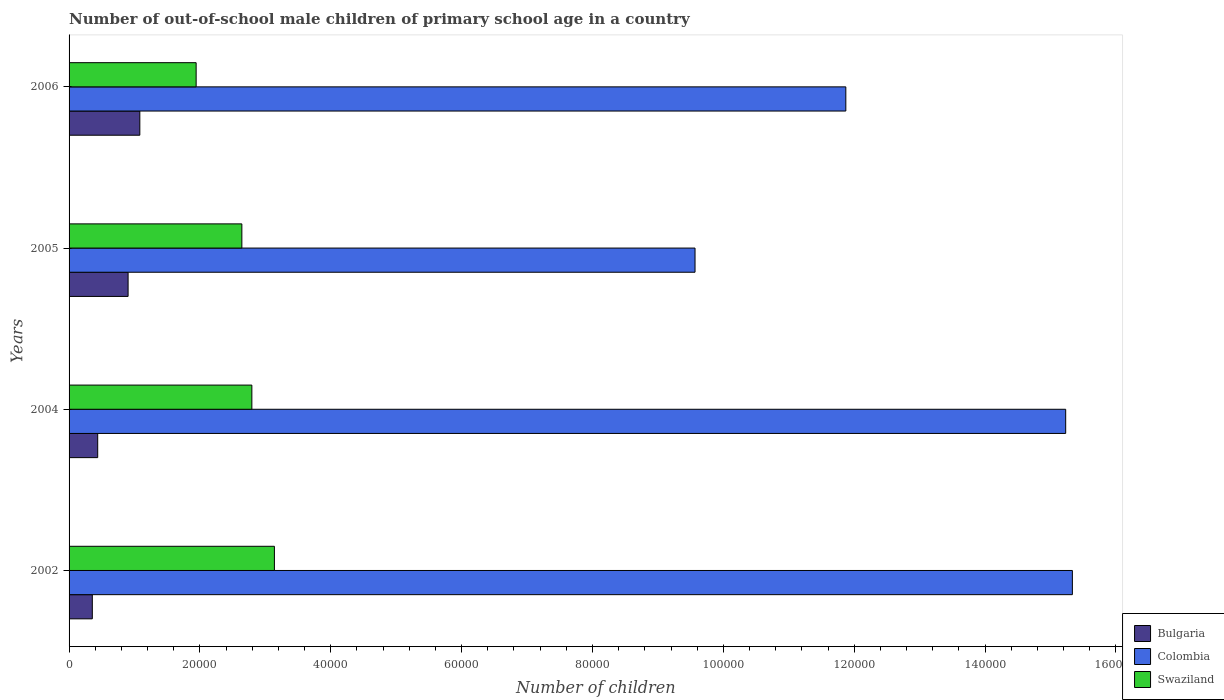Are the number of bars per tick equal to the number of legend labels?
Offer a very short reply. Yes. Are the number of bars on each tick of the Y-axis equal?
Make the answer very short. Yes. How many bars are there on the 4th tick from the bottom?
Provide a short and direct response. 3. What is the label of the 3rd group of bars from the top?
Your answer should be compact. 2004. In how many cases, is the number of bars for a given year not equal to the number of legend labels?
Provide a short and direct response. 0. What is the number of out-of-school male children in Colombia in 2005?
Provide a succinct answer. 9.57e+04. Across all years, what is the maximum number of out-of-school male children in Colombia?
Make the answer very short. 1.53e+05. Across all years, what is the minimum number of out-of-school male children in Swaziland?
Offer a very short reply. 1.94e+04. In which year was the number of out-of-school male children in Colombia maximum?
Provide a short and direct response. 2002. In which year was the number of out-of-school male children in Colombia minimum?
Provide a succinct answer. 2005. What is the total number of out-of-school male children in Colombia in the graph?
Your answer should be very brief. 5.20e+05. What is the difference between the number of out-of-school male children in Bulgaria in 2005 and that in 2006?
Make the answer very short. -1793. What is the difference between the number of out-of-school male children in Colombia in 2004 and the number of out-of-school male children in Swaziland in 2006?
Ensure brevity in your answer.  1.33e+05. What is the average number of out-of-school male children in Bulgaria per year?
Ensure brevity in your answer.  6941.25. In the year 2005, what is the difference between the number of out-of-school male children in Bulgaria and number of out-of-school male children in Colombia?
Offer a very short reply. -8.66e+04. What is the ratio of the number of out-of-school male children in Swaziland in 2002 to that in 2006?
Offer a very short reply. 1.62. Is the difference between the number of out-of-school male children in Bulgaria in 2005 and 2006 greater than the difference between the number of out-of-school male children in Colombia in 2005 and 2006?
Provide a short and direct response. Yes. What is the difference between the highest and the second highest number of out-of-school male children in Colombia?
Your answer should be compact. 1021. What is the difference between the highest and the lowest number of out-of-school male children in Bulgaria?
Keep it short and to the point. 7262. In how many years, is the number of out-of-school male children in Swaziland greater than the average number of out-of-school male children in Swaziland taken over all years?
Make the answer very short. 3. Is the sum of the number of out-of-school male children in Swaziland in 2005 and 2006 greater than the maximum number of out-of-school male children in Bulgaria across all years?
Offer a very short reply. Yes. What does the 1st bar from the bottom in 2004 represents?
Your answer should be compact. Bulgaria. Are all the bars in the graph horizontal?
Your answer should be very brief. Yes. What is the difference between two consecutive major ticks on the X-axis?
Ensure brevity in your answer.  2.00e+04. Does the graph contain any zero values?
Offer a very short reply. No. Where does the legend appear in the graph?
Offer a terse response. Bottom right. How many legend labels are there?
Give a very brief answer. 3. How are the legend labels stacked?
Provide a succinct answer. Vertical. What is the title of the graph?
Ensure brevity in your answer.  Number of out-of-school male children of primary school age in a country. What is the label or title of the X-axis?
Make the answer very short. Number of children. What is the label or title of the Y-axis?
Your response must be concise. Years. What is the Number of children in Bulgaria in 2002?
Give a very brief answer. 3553. What is the Number of children of Colombia in 2002?
Keep it short and to the point. 1.53e+05. What is the Number of children of Swaziland in 2002?
Make the answer very short. 3.14e+04. What is the Number of children of Bulgaria in 2004?
Ensure brevity in your answer.  4375. What is the Number of children in Colombia in 2004?
Offer a terse response. 1.52e+05. What is the Number of children in Swaziland in 2004?
Provide a short and direct response. 2.79e+04. What is the Number of children in Bulgaria in 2005?
Your answer should be compact. 9022. What is the Number of children of Colombia in 2005?
Keep it short and to the point. 9.57e+04. What is the Number of children in Swaziland in 2005?
Provide a short and direct response. 2.64e+04. What is the Number of children in Bulgaria in 2006?
Provide a short and direct response. 1.08e+04. What is the Number of children in Colombia in 2006?
Ensure brevity in your answer.  1.19e+05. What is the Number of children in Swaziland in 2006?
Keep it short and to the point. 1.94e+04. Across all years, what is the maximum Number of children in Bulgaria?
Ensure brevity in your answer.  1.08e+04. Across all years, what is the maximum Number of children of Colombia?
Offer a terse response. 1.53e+05. Across all years, what is the maximum Number of children in Swaziland?
Offer a terse response. 3.14e+04. Across all years, what is the minimum Number of children of Bulgaria?
Ensure brevity in your answer.  3553. Across all years, what is the minimum Number of children of Colombia?
Make the answer very short. 9.57e+04. Across all years, what is the minimum Number of children in Swaziland?
Your answer should be compact. 1.94e+04. What is the total Number of children of Bulgaria in the graph?
Your answer should be very brief. 2.78e+04. What is the total Number of children in Colombia in the graph?
Your answer should be very brief. 5.20e+05. What is the total Number of children of Swaziland in the graph?
Offer a very short reply. 1.05e+05. What is the difference between the Number of children in Bulgaria in 2002 and that in 2004?
Your response must be concise. -822. What is the difference between the Number of children of Colombia in 2002 and that in 2004?
Offer a very short reply. 1021. What is the difference between the Number of children in Swaziland in 2002 and that in 2004?
Offer a very short reply. 3445. What is the difference between the Number of children of Bulgaria in 2002 and that in 2005?
Make the answer very short. -5469. What is the difference between the Number of children of Colombia in 2002 and that in 2005?
Provide a short and direct response. 5.77e+04. What is the difference between the Number of children of Swaziland in 2002 and that in 2005?
Provide a succinct answer. 4974. What is the difference between the Number of children in Bulgaria in 2002 and that in 2006?
Your answer should be very brief. -7262. What is the difference between the Number of children of Colombia in 2002 and that in 2006?
Make the answer very short. 3.46e+04. What is the difference between the Number of children of Swaziland in 2002 and that in 2006?
Your response must be concise. 1.20e+04. What is the difference between the Number of children of Bulgaria in 2004 and that in 2005?
Keep it short and to the point. -4647. What is the difference between the Number of children of Colombia in 2004 and that in 2005?
Keep it short and to the point. 5.67e+04. What is the difference between the Number of children in Swaziland in 2004 and that in 2005?
Provide a short and direct response. 1529. What is the difference between the Number of children of Bulgaria in 2004 and that in 2006?
Keep it short and to the point. -6440. What is the difference between the Number of children in Colombia in 2004 and that in 2006?
Your answer should be compact. 3.36e+04. What is the difference between the Number of children in Swaziland in 2004 and that in 2006?
Make the answer very short. 8516. What is the difference between the Number of children of Bulgaria in 2005 and that in 2006?
Make the answer very short. -1793. What is the difference between the Number of children in Colombia in 2005 and that in 2006?
Your response must be concise. -2.30e+04. What is the difference between the Number of children in Swaziland in 2005 and that in 2006?
Your answer should be compact. 6987. What is the difference between the Number of children of Bulgaria in 2002 and the Number of children of Colombia in 2004?
Make the answer very short. -1.49e+05. What is the difference between the Number of children of Bulgaria in 2002 and the Number of children of Swaziland in 2004?
Your answer should be very brief. -2.44e+04. What is the difference between the Number of children of Colombia in 2002 and the Number of children of Swaziland in 2004?
Make the answer very short. 1.25e+05. What is the difference between the Number of children of Bulgaria in 2002 and the Number of children of Colombia in 2005?
Ensure brevity in your answer.  -9.21e+04. What is the difference between the Number of children of Bulgaria in 2002 and the Number of children of Swaziland in 2005?
Offer a very short reply. -2.29e+04. What is the difference between the Number of children of Colombia in 2002 and the Number of children of Swaziland in 2005?
Your response must be concise. 1.27e+05. What is the difference between the Number of children in Bulgaria in 2002 and the Number of children in Colombia in 2006?
Provide a short and direct response. -1.15e+05. What is the difference between the Number of children of Bulgaria in 2002 and the Number of children of Swaziland in 2006?
Ensure brevity in your answer.  -1.59e+04. What is the difference between the Number of children of Colombia in 2002 and the Number of children of Swaziland in 2006?
Ensure brevity in your answer.  1.34e+05. What is the difference between the Number of children in Bulgaria in 2004 and the Number of children in Colombia in 2005?
Your answer should be compact. -9.13e+04. What is the difference between the Number of children of Bulgaria in 2004 and the Number of children of Swaziland in 2005?
Give a very brief answer. -2.20e+04. What is the difference between the Number of children of Colombia in 2004 and the Number of children of Swaziland in 2005?
Offer a terse response. 1.26e+05. What is the difference between the Number of children of Bulgaria in 2004 and the Number of children of Colombia in 2006?
Offer a very short reply. -1.14e+05. What is the difference between the Number of children of Bulgaria in 2004 and the Number of children of Swaziland in 2006?
Your answer should be compact. -1.50e+04. What is the difference between the Number of children in Colombia in 2004 and the Number of children in Swaziland in 2006?
Ensure brevity in your answer.  1.33e+05. What is the difference between the Number of children of Bulgaria in 2005 and the Number of children of Colombia in 2006?
Provide a short and direct response. -1.10e+05. What is the difference between the Number of children in Bulgaria in 2005 and the Number of children in Swaziland in 2006?
Your answer should be very brief. -1.04e+04. What is the difference between the Number of children of Colombia in 2005 and the Number of children of Swaziland in 2006?
Keep it short and to the point. 7.62e+04. What is the average Number of children of Bulgaria per year?
Offer a terse response. 6941.25. What is the average Number of children in Colombia per year?
Provide a succinct answer. 1.30e+05. What is the average Number of children in Swaziland per year?
Offer a very short reply. 2.63e+04. In the year 2002, what is the difference between the Number of children of Bulgaria and Number of children of Colombia?
Offer a very short reply. -1.50e+05. In the year 2002, what is the difference between the Number of children in Bulgaria and Number of children in Swaziland?
Keep it short and to the point. -2.78e+04. In the year 2002, what is the difference between the Number of children in Colombia and Number of children in Swaziland?
Offer a terse response. 1.22e+05. In the year 2004, what is the difference between the Number of children in Bulgaria and Number of children in Colombia?
Ensure brevity in your answer.  -1.48e+05. In the year 2004, what is the difference between the Number of children in Bulgaria and Number of children in Swaziland?
Your response must be concise. -2.36e+04. In the year 2004, what is the difference between the Number of children in Colombia and Number of children in Swaziland?
Your answer should be compact. 1.24e+05. In the year 2005, what is the difference between the Number of children of Bulgaria and Number of children of Colombia?
Your response must be concise. -8.66e+04. In the year 2005, what is the difference between the Number of children of Bulgaria and Number of children of Swaziland?
Provide a short and direct response. -1.74e+04. In the year 2005, what is the difference between the Number of children in Colombia and Number of children in Swaziland?
Your answer should be compact. 6.93e+04. In the year 2006, what is the difference between the Number of children of Bulgaria and Number of children of Colombia?
Your response must be concise. -1.08e+05. In the year 2006, what is the difference between the Number of children in Bulgaria and Number of children in Swaziland?
Keep it short and to the point. -8606. In the year 2006, what is the difference between the Number of children in Colombia and Number of children in Swaziland?
Provide a short and direct response. 9.93e+04. What is the ratio of the Number of children of Bulgaria in 2002 to that in 2004?
Your response must be concise. 0.81. What is the ratio of the Number of children in Colombia in 2002 to that in 2004?
Offer a terse response. 1.01. What is the ratio of the Number of children in Swaziland in 2002 to that in 2004?
Offer a terse response. 1.12. What is the ratio of the Number of children in Bulgaria in 2002 to that in 2005?
Make the answer very short. 0.39. What is the ratio of the Number of children of Colombia in 2002 to that in 2005?
Your answer should be compact. 1.6. What is the ratio of the Number of children in Swaziland in 2002 to that in 2005?
Your answer should be compact. 1.19. What is the ratio of the Number of children in Bulgaria in 2002 to that in 2006?
Provide a succinct answer. 0.33. What is the ratio of the Number of children of Colombia in 2002 to that in 2006?
Give a very brief answer. 1.29. What is the ratio of the Number of children of Swaziland in 2002 to that in 2006?
Keep it short and to the point. 1.62. What is the ratio of the Number of children in Bulgaria in 2004 to that in 2005?
Make the answer very short. 0.48. What is the ratio of the Number of children of Colombia in 2004 to that in 2005?
Give a very brief answer. 1.59. What is the ratio of the Number of children of Swaziland in 2004 to that in 2005?
Offer a very short reply. 1.06. What is the ratio of the Number of children of Bulgaria in 2004 to that in 2006?
Your answer should be compact. 0.4. What is the ratio of the Number of children of Colombia in 2004 to that in 2006?
Your answer should be very brief. 1.28. What is the ratio of the Number of children of Swaziland in 2004 to that in 2006?
Ensure brevity in your answer.  1.44. What is the ratio of the Number of children of Bulgaria in 2005 to that in 2006?
Give a very brief answer. 0.83. What is the ratio of the Number of children of Colombia in 2005 to that in 2006?
Keep it short and to the point. 0.81. What is the ratio of the Number of children of Swaziland in 2005 to that in 2006?
Provide a short and direct response. 1.36. What is the difference between the highest and the second highest Number of children of Bulgaria?
Your answer should be very brief. 1793. What is the difference between the highest and the second highest Number of children of Colombia?
Your answer should be compact. 1021. What is the difference between the highest and the second highest Number of children in Swaziland?
Your answer should be compact. 3445. What is the difference between the highest and the lowest Number of children in Bulgaria?
Give a very brief answer. 7262. What is the difference between the highest and the lowest Number of children of Colombia?
Provide a short and direct response. 5.77e+04. What is the difference between the highest and the lowest Number of children in Swaziland?
Provide a succinct answer. 1.20e+04. 